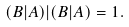Convert formula to latex. <formula><loc_0><loc_0><loc_500><loc_500>( B | A ) | ( B | A ) = 1 .</formula> 